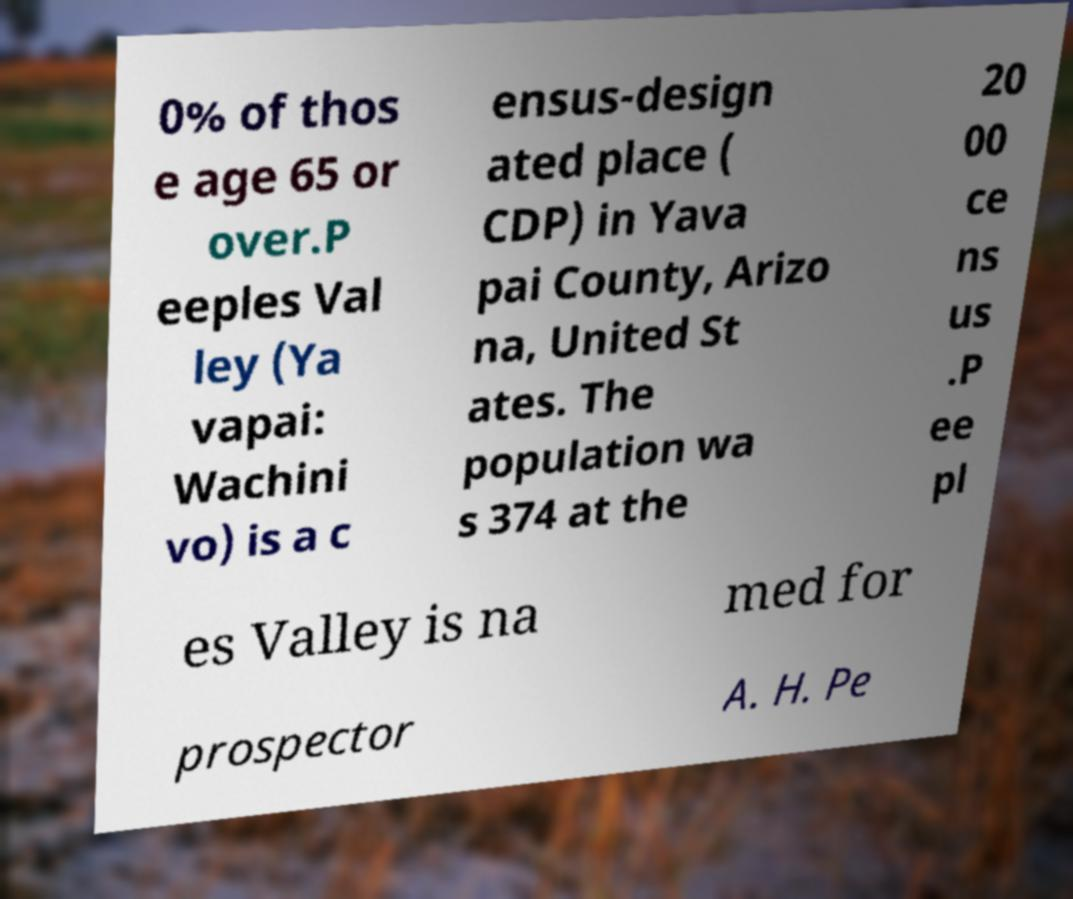For documentation purposes, I need the text within this image transcribed. Could you provide that? 0% of thos e age 65 or over.P eeples Val ley (Ya vapai: Wachini vo) is a c ensus-design ated place ( CDP) in Yava pai County, Arizo na, United St ates. The population wa s 374 at the 20 00 ce ns us .P ee pl es Valley is na med for prospector A. H. Pe 